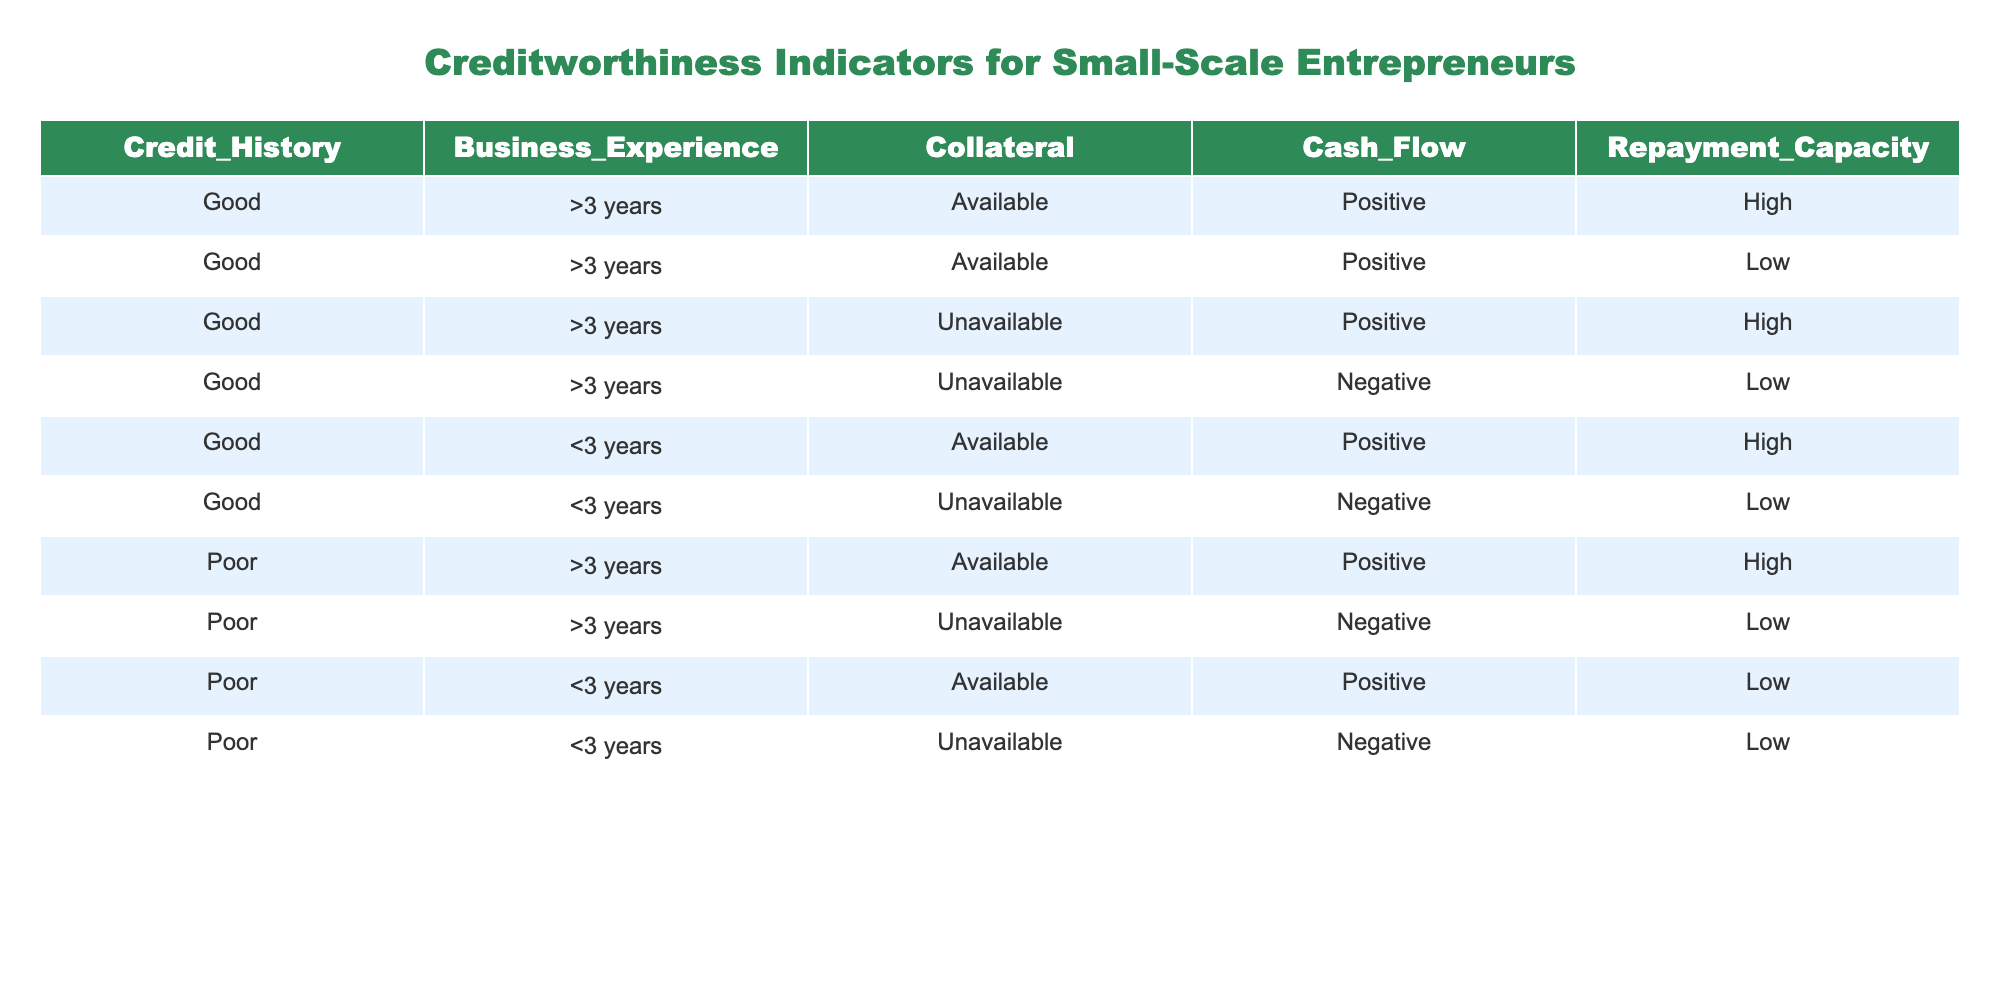What's the number of entries with good credit history? By looking at the "Credit_History" column, there are six entries labeled as "Good." Each row represents an individual entry, and we count them to arrive at this total.
Answer: 6 How many entries have collateral available and a high repayment capacity? We filter the table for entries that have "Available" under the "Collateral" column and "High" under the "Repayment_Capacity" column. There are three such entries: (Good, >3 years, Available, Positive, High), (Good, <3 years, Available, Positive, High), and (Poor, >3 years, Available, Positive, High).
Answer: 3 Does a negative cash flow always correlate with a low repayment capacity? By examining the "Cash_Flow" and "Repayment_Capacity" columns, we see that both entries with a "Negative" cash flow also have "Low" repayment capacity, thus confirming the correlation. However, we must note that this is based on the current dataset only.
Answer: Yes What is the total number of entries with poor credit history and less than three years of business experience? We count the entries under "Credit_History" that are marked as "Poor" and simultaneously check for "<3 years" under "Business_Experience." Upon examination, there are four entries fitting this description: (Poor, <3 years, Available, Positive, Low), (Poor, <3 years, Unavailable, Negative, Low).
Answer: 4 In cases of good credit history but unavailable collateral, how many have a high repayment capacity? We look for entries where "Credit_History" is "Good," "Collateral" is "Unavailable," and "Repayment_Capacity" is "High." There is one entry that meets all these conditions: (Good, >3 years, Unavailable, Positive, High).
Answer: 1 What's the difference in the number of entries with positive cash flow versus those with negative cash flow? To find this difference, we count the entries with "Positive" cash flow (6 entries) and the entries with "Negative" cash flow (4 entries). The difference is calculated as 6 - 4 = 2.
Answer: 2 Are there any entrepreneurs with good credit history and less than three years of business experience who have low repayment capacity? Checking the entries under those conditions, we see one matching entry: (Good, <3 years, Unavailable, Negative, Low). Thus, the answer is verified against the table's data.
Answer: Yes How many entrepreneurs have good credit history and have a positive cash flow? We look for "Good" under the "Credit_History" column and "Positive" under the "Cash_Flow" column and find that there are five entries that match these criteria.
Answer: 5 